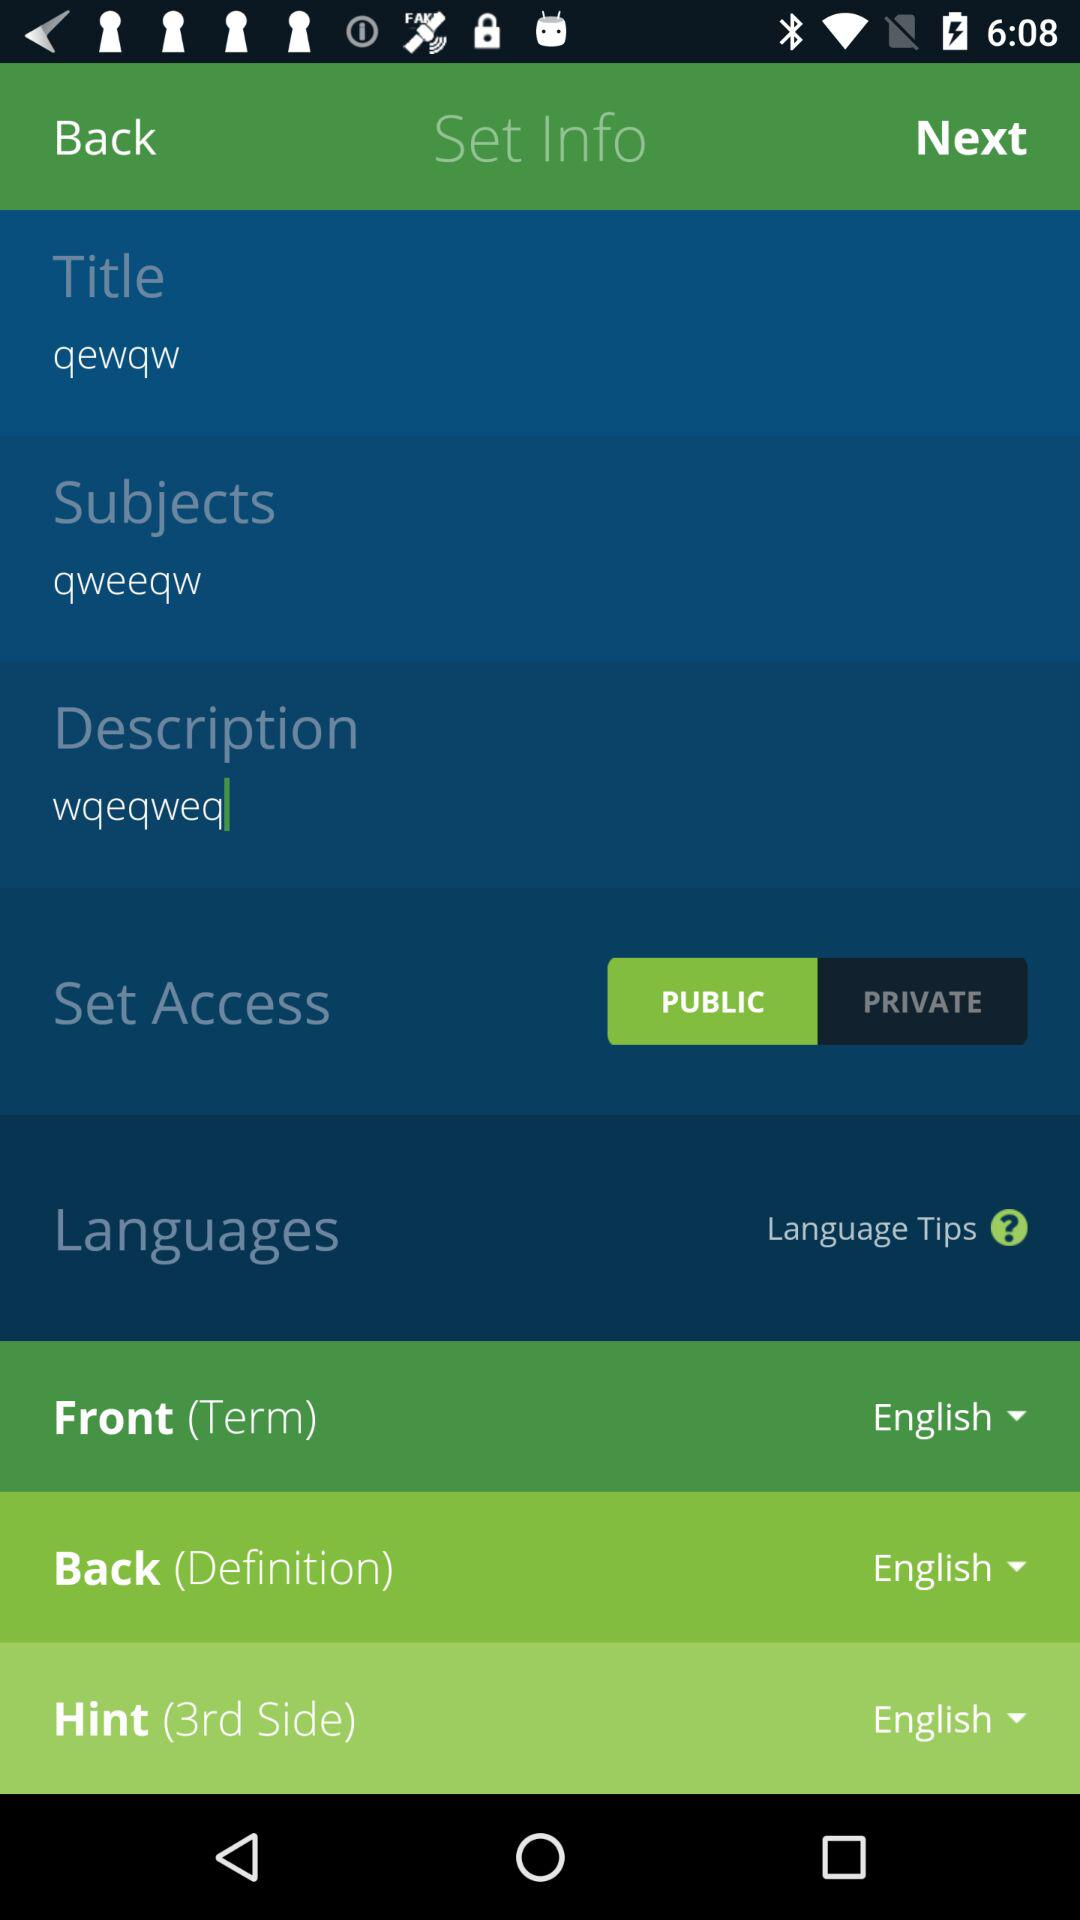What is the selected hint? The selected hint is English. 